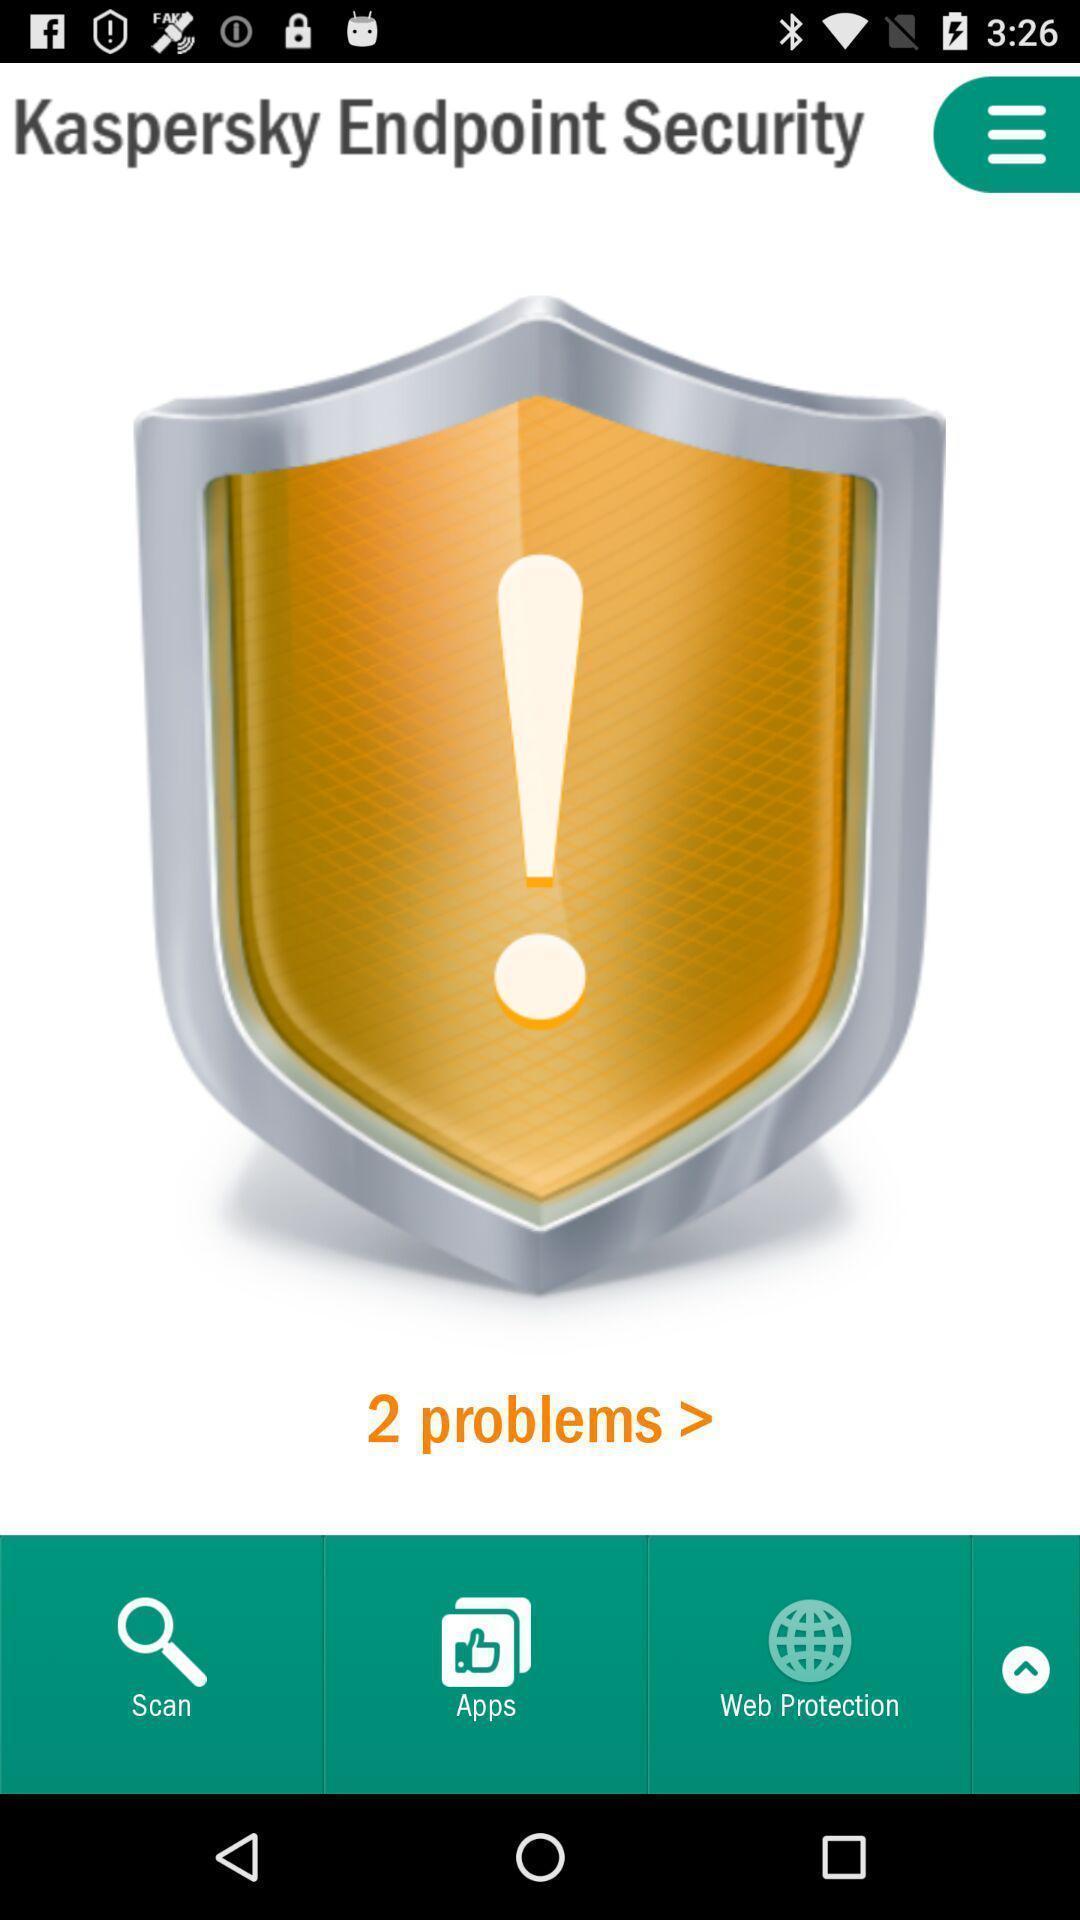Describe the content in this image. Set of options in a security app. 